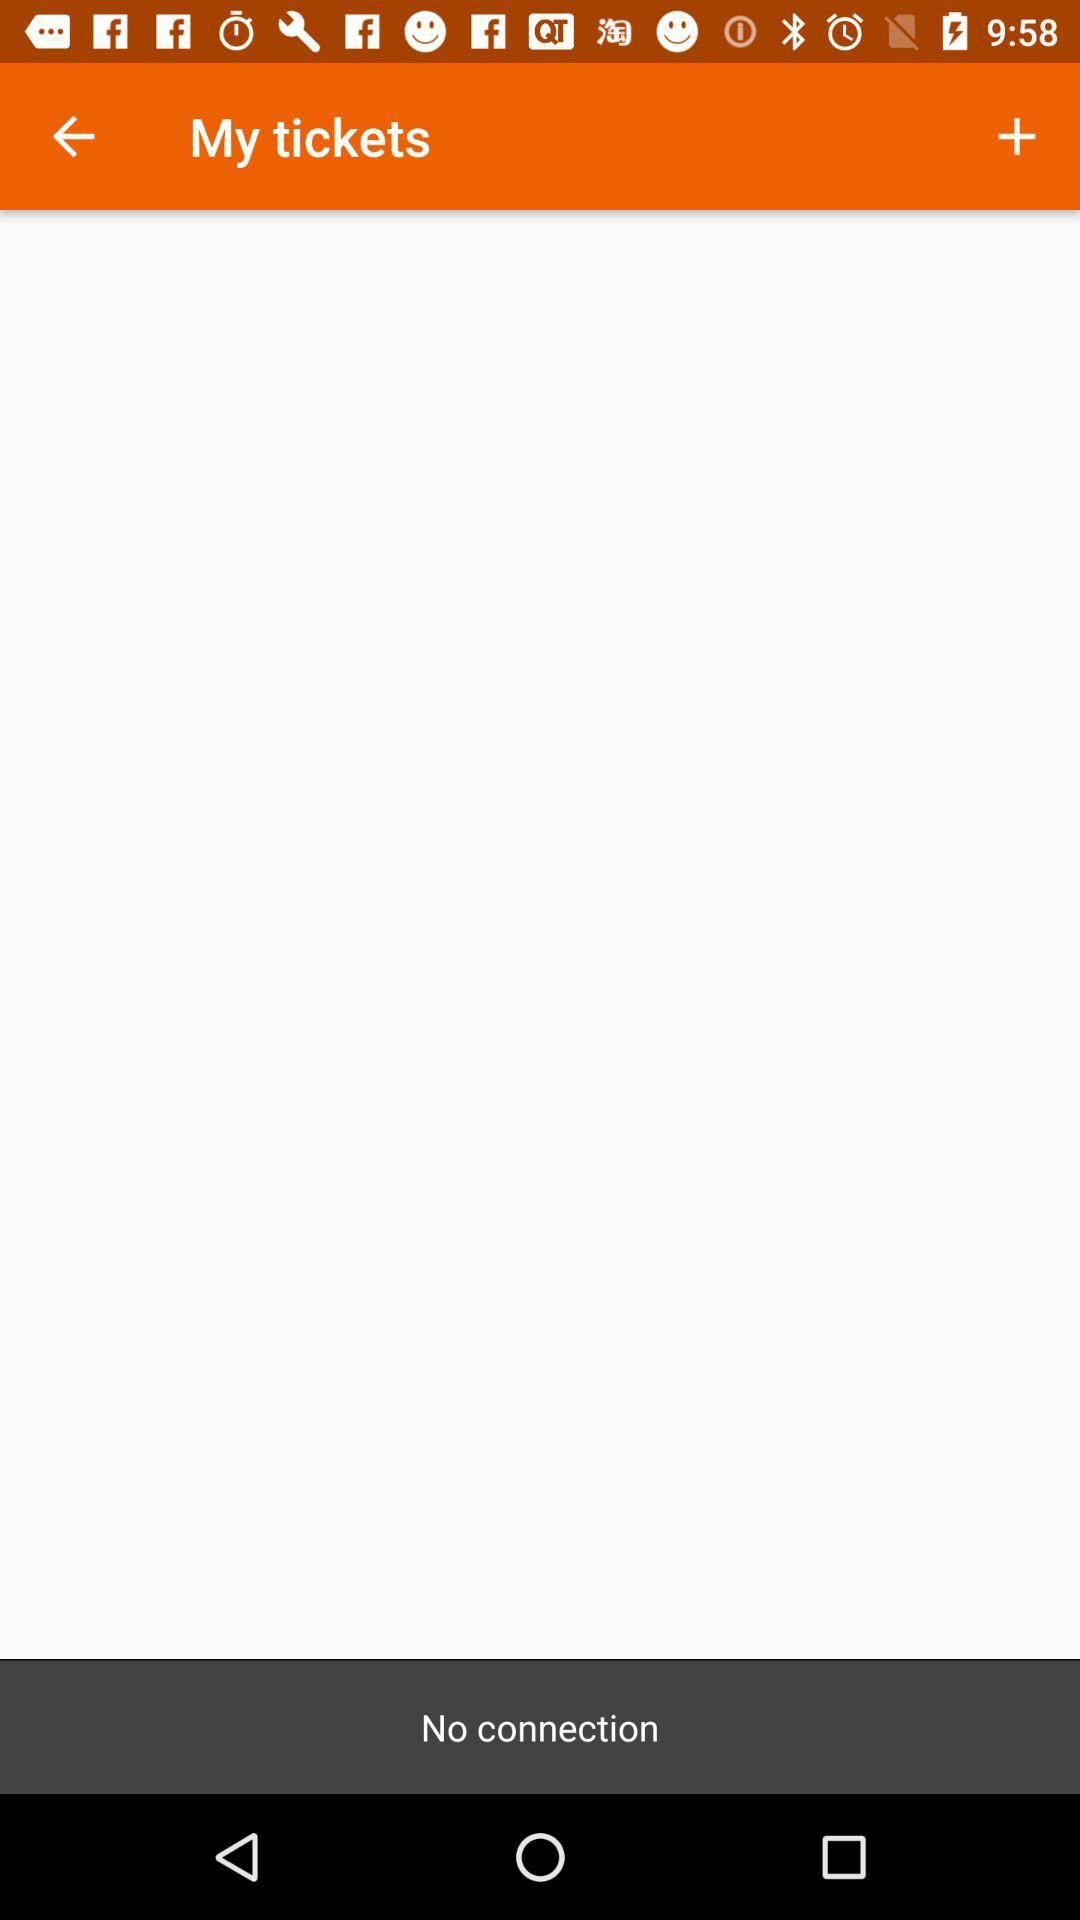Is there any connection? There is no connection. 